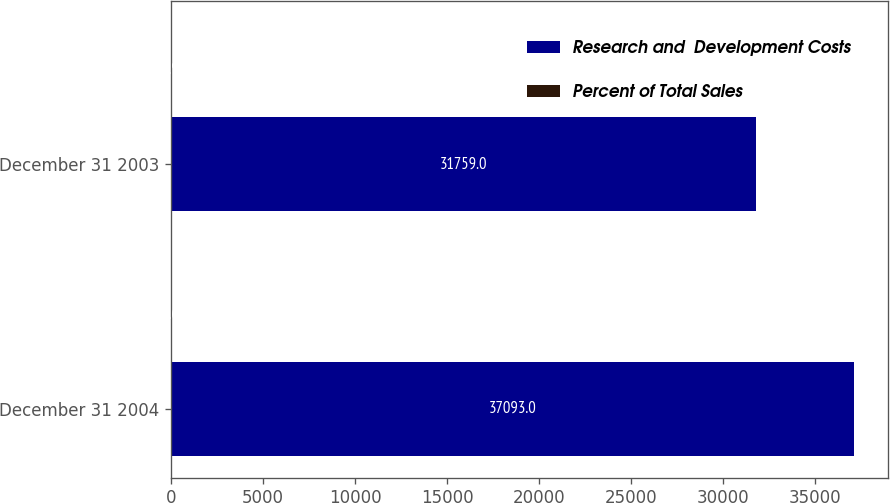Convert chart to OTSL. <chart><loc_0><loc_0><loc_500><loc_500><stacked_bar_chart><ecel><fcel>December 31 2004<fcel>December 31 2003<nl><fcel>Research and  Development Costs<fcel>37093<fcel>31759<nl><fcel>Percent of Total Sales<fcel>5.6<fcel>5.9<nl></chart> 